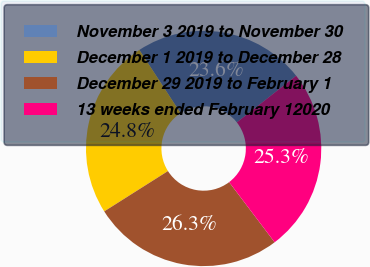Convert chart. <chart><loc_0><loc_0><loc_500><loc_500><pie_chart><fcel>November 3 2019 to November 30<fcel>December 1 2019 to December 28<fcel>December 29 2019 to February 1<fcel>13 weeks ended February 12020<nl><fcel>23.6%<fcel>24.78%<fcel>26.33%<fcel>25.29%<nl></chart> 